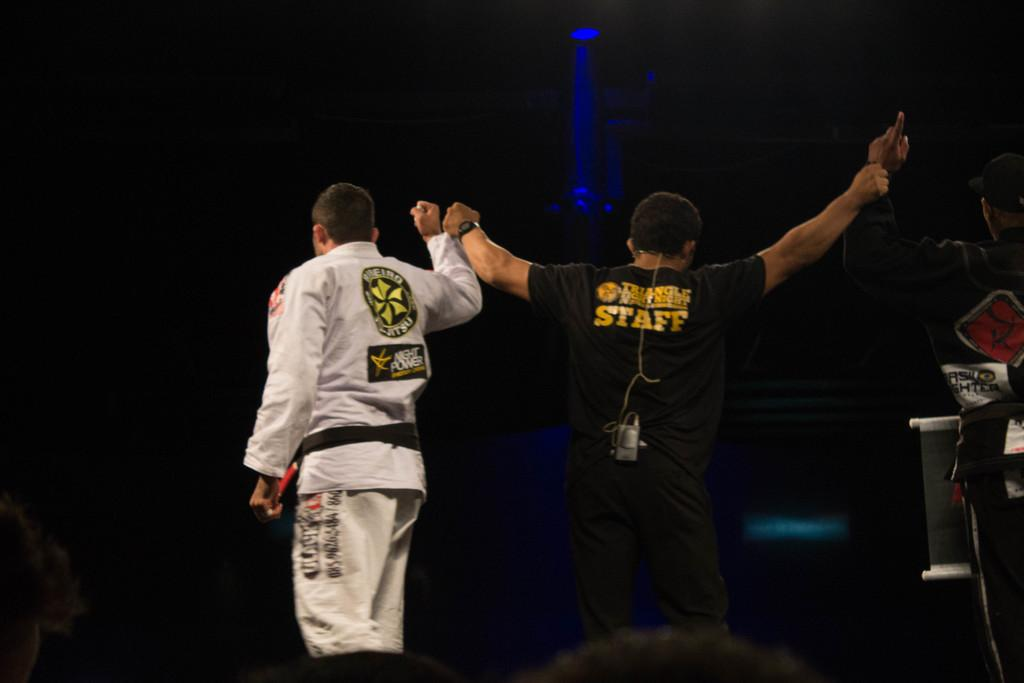<image>
Render a clear and concise summary of the photo. a man holding up another hand with the word staff on his back 